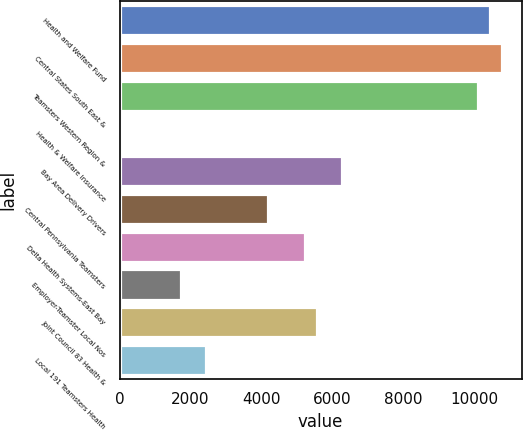<chart> <loc_0><loc_0><loc_500><loc_500><bar_chart><fcel>Health and Welfare Fund<fcel>Central States South East &<fcel>Teamsters Western Region &<fcel>Health & Welfare Insurance<fcel>Bay Area Delivery Drivers<fcel>Central Pennsylvania Teamsters<fcel>Delta Health Systems-East Bay<fcel>Employer-Teamster Local Nos<fcel>Joint Council 83 Health &<fcel>Local 191 Teamsters Health<nl><fcel>10446<fcel>10794<fcel>10098<fcel>6<fcel>6270<fcel>4182<fcel>5226<fcel>1746<fcel>5574<fcel>2442<nl></chart> 